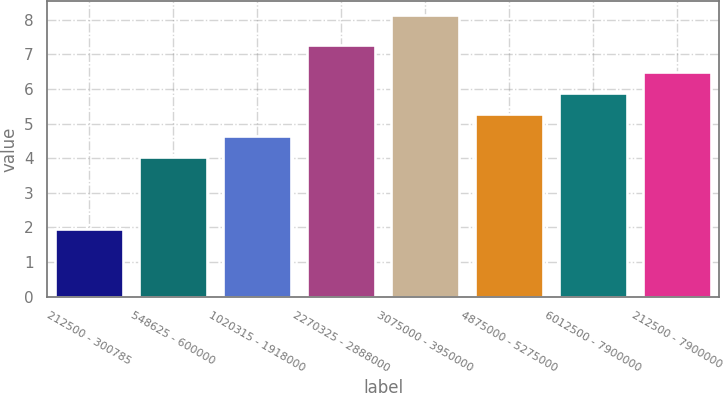<chart> <loc_0><loc_0><loc_500><loc_500><bar_chart><fcel>212500 - 300785<fcel>548625 - 600000<fcel>1020315 - 1918000<fcel>2270325 - 2888000<fcel>3075000 - 3950000<fcel>4875000 - 5275000<fcel>6012500 - 7900000<fcel>212500 - 7900000<nl><fcel>1.96<fcel>4.02<fcel>4.64<fcel>7.26<fcel>8.12<fcel>5.26<fcel>5.88<fcel>6.5<nl></chart> 